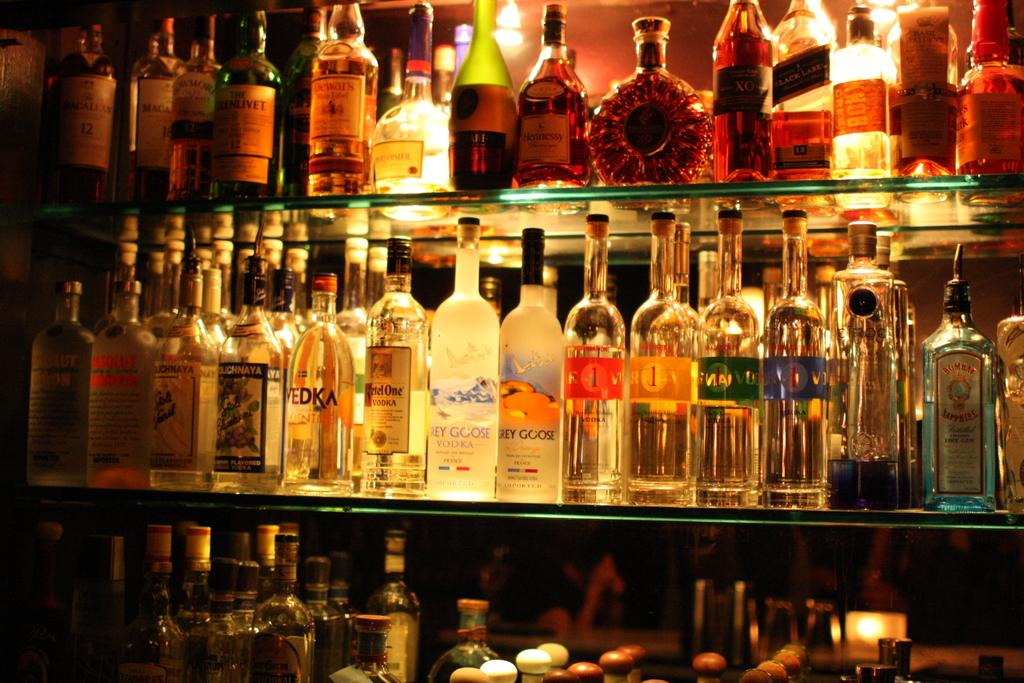<image>
Create a compact narrative representing the image presented. Some bottles of alcohol including Grey Goose vodka. 